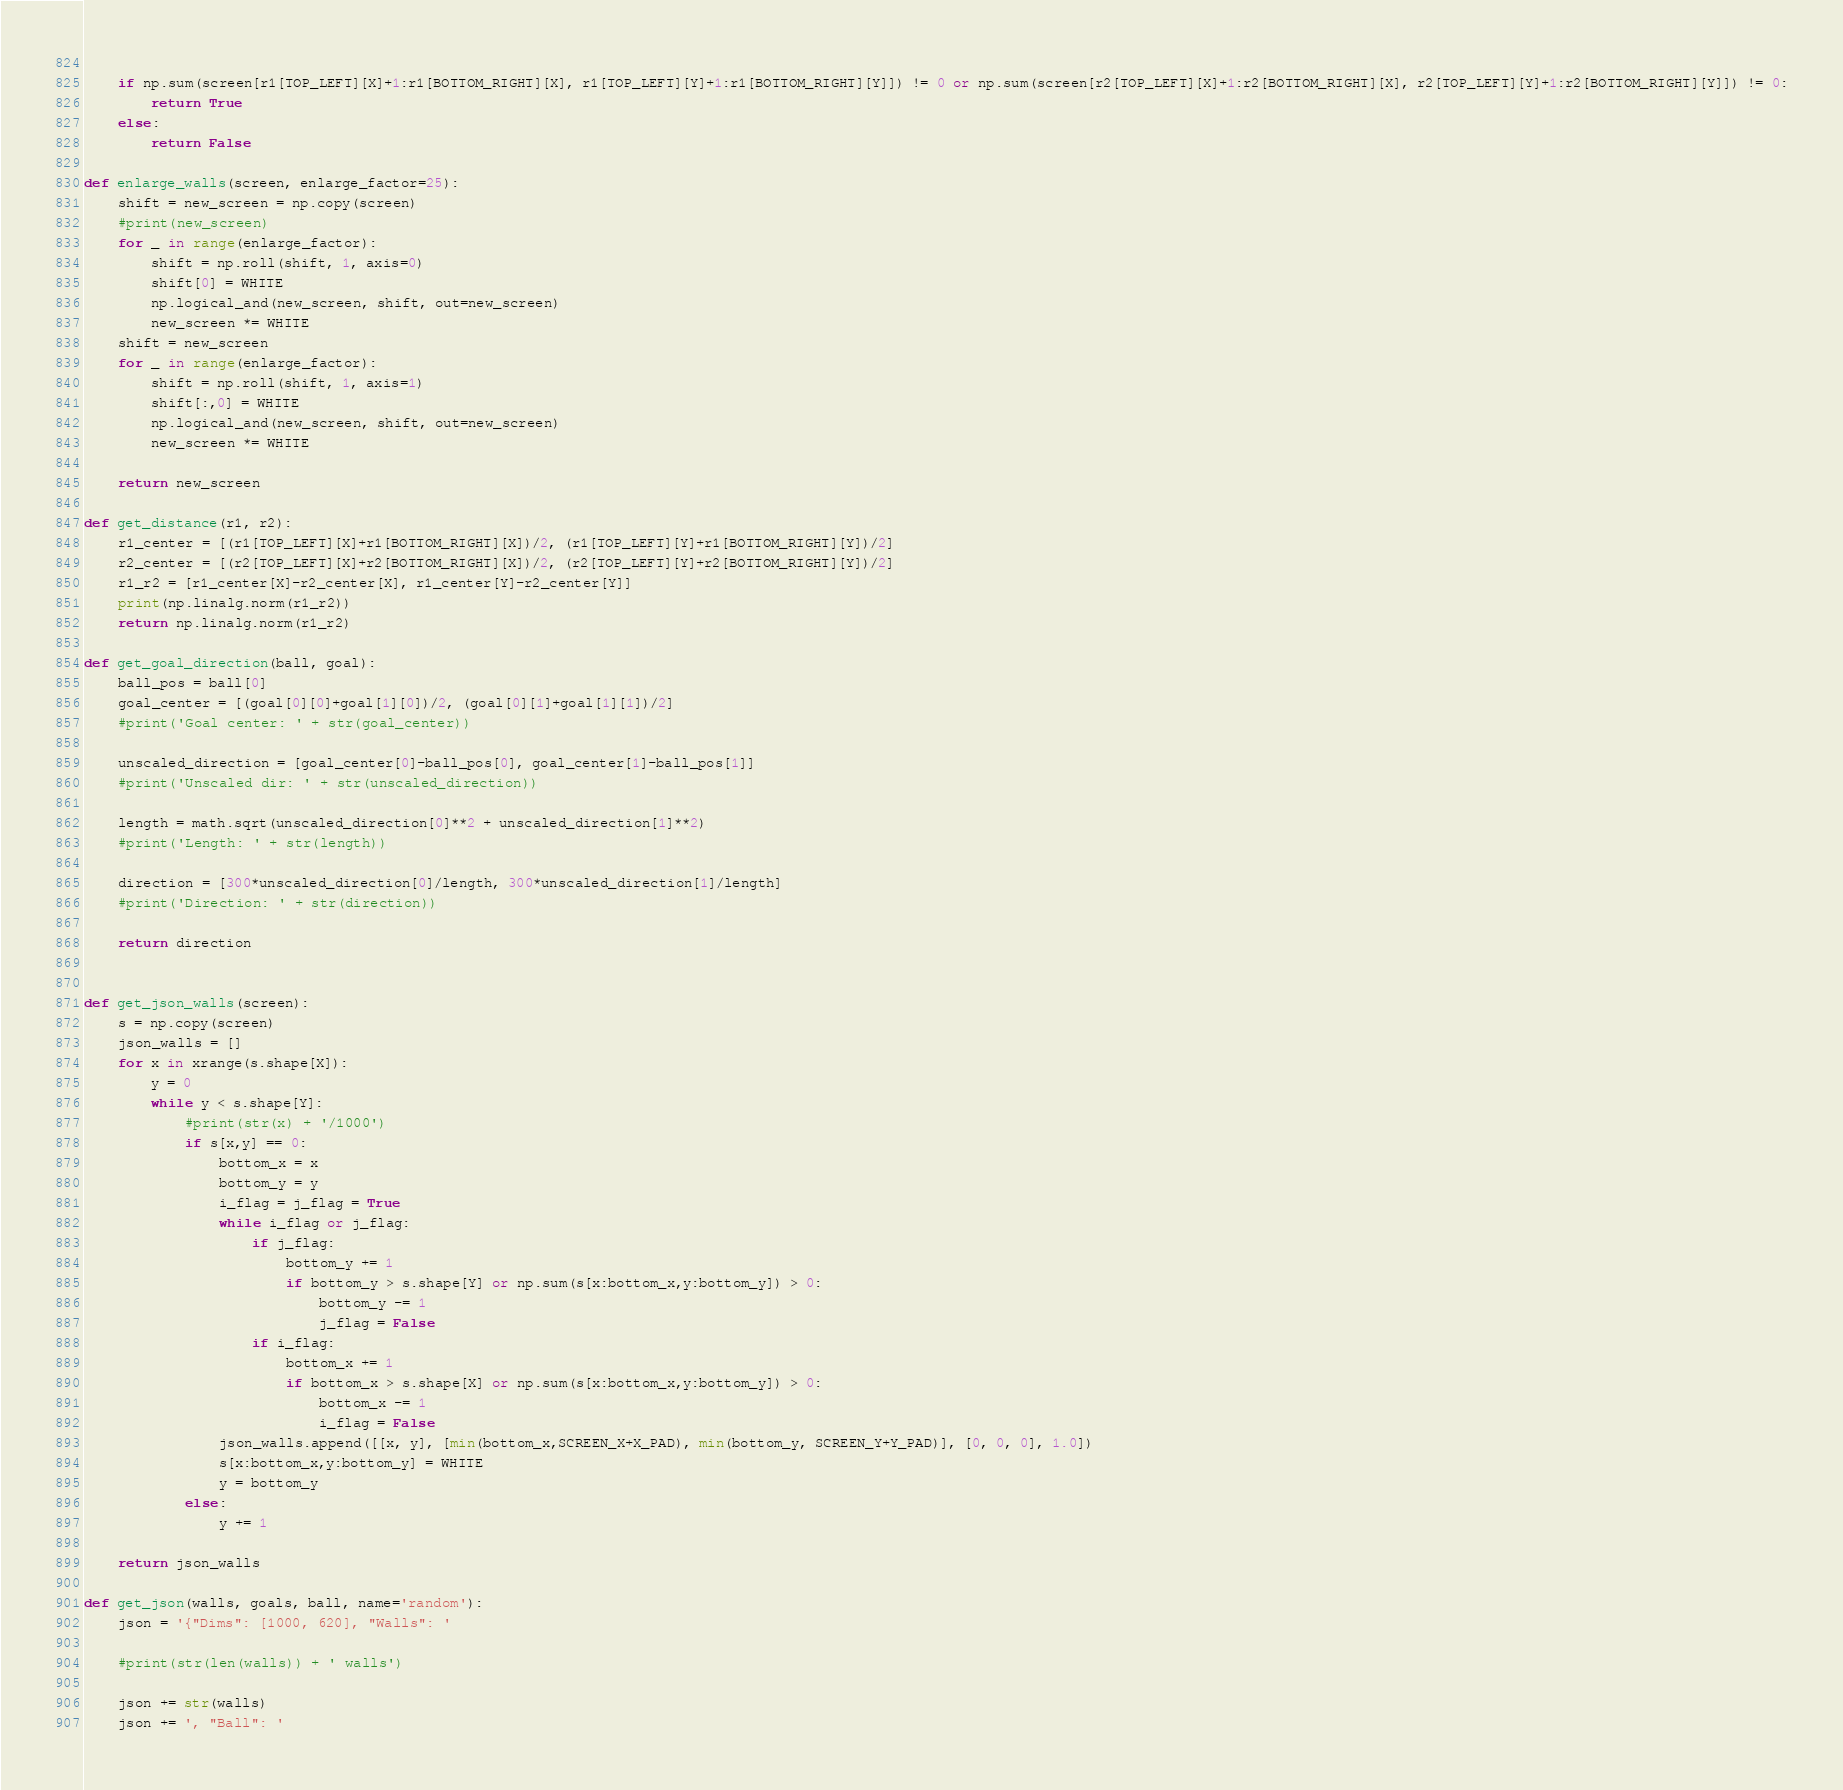Convert code to text. <code><loc_0><loc_0><loc_500><loc_500><_Python_>    
    if np.sum(screen[r1[TOP_LEFT][X]+1:r1[BOTTOM_RIGHT][X], r1[TOP_LEFT][Y]+1:r1[BOTTOM_RIGHT][Y]]) != 0 or np.sum(screen[r2[TOP_LEFT][X]+1:r2[BOTTOM_RIGHT][X], r2[TOP_LEFT][Y]+1:r2[BOTTOM_RIGHT][Y]]) != 0:
        return True
    else:
        return False

def enlarge_walls(screen, enlarge_factor=25):
    shift = new_screen = np.copy(screen)
    #print(new_screen)
    for _ in range(enlarge_factor):
        shift = np.roll(shift, 1, axis=0)
        shift[0] = WHITE
        np.logical_and(new_screen, shift, out=new_screen)
        new_screen *= WHITE
    shift = new_screen
    for _ in range(enlarge_factor):
        shift = np.roll(shift, 1, axis=1)
        shift[:,0] = WHITE
        np.logical_and(new_screen, shift, out=new_screen)
        new_screen *= WHITE
    
    return new_screen

def get_distance(r1, r2):
    r1_center = [(r1[TOP_LEFT][X]+r1[BOTTOM_RIGHT][X])/2, (r1[TOP_LEFT][Y]+r1[BOTTOM_RIGHT][Y])/2]
    r2_center = [(r2[TOP_LEFT][X]+r2[BOTTOM_RIGHT][X])/2, (r2[TOP_LEFT][Y]+r2[BOTTOM_RIGHT][Y])/2]
    r1_r2 = [r1_center[X]-r2_center[X], r1_center[Y]-r2_center[Y]]
    print(np.linalg.norm(r1_r2))
    return np.linalg.norm(r1_r2)

def get_goal_direction(ball, goal):
    ball_pos = ball[0]
    goal_center = [(goal[0][0]+goal[1][0])/2, (goal[0][1]+goal[1][1])/2]
    #print('Goal center: ' + str(goal_center))
    
    unscaled_direction = [goal_center[0]-ball_pos[0], goal_center[1]-ball_pos[1]]
    #print('Unscaled dir: ' + str(unscaled_direction))

    length = math.sqrt(unscaled_direction[0]**2 + unscaled_direction[1]**2)
    #print('Length: ' + str(length))

    direction = [300*unscaled_direction[0]/length, 300*unscaled_direction[1]/length]
    #print('Direction: ' + str(direction))

    return direction


def get_json_walls(screen):
    s = np.copy(screen)
    json_walls = []
    for x in xrange(s.shape[X]):
        y = 0
        while y < s.shape[Y]:
            #print(str(x) + '/1000')
            if s[x,y] == 0:
                bottom_x = x
                bottom_y = y
                i_flag = j_flag = True
                while i_flag or j_flag:
                    if j_flag:
                        bottom_y += 1
                        if bottom_y > s.shape[Y] or np.sum(s[x:bottom_x,y:bottom_y]) > 0:
                            bottom_y -= 1
                            j_flag = False
                    if i_flag:
                        bottom_x += 1
                        if bottom_x > s.shape[X] or np.sum(s[x:bottom_x,y:bottom_y]) > 0:
                            bottom_x -= 1
                            i_flag = False
                json_walls.append([[x, y], [min(bottom_x,SCREEN_X+X_PAD), min(bottom_y, SCREEN_Y+Y_PAD)], [0, 0, 0], 1.0])
                s[x:bottom_x,y:bottom_y] = WHITE
                y = bottom_y
            else:
                y += 1

    return json_walls

def get_json(walls, goals, ball, name='random'):
    json = '{"Dims": [1000, 620], "Walls": '
    
    #print(str(len(walls)) + ' walls')

    json += str(walls)
    json += ', "Ball": '</code> 